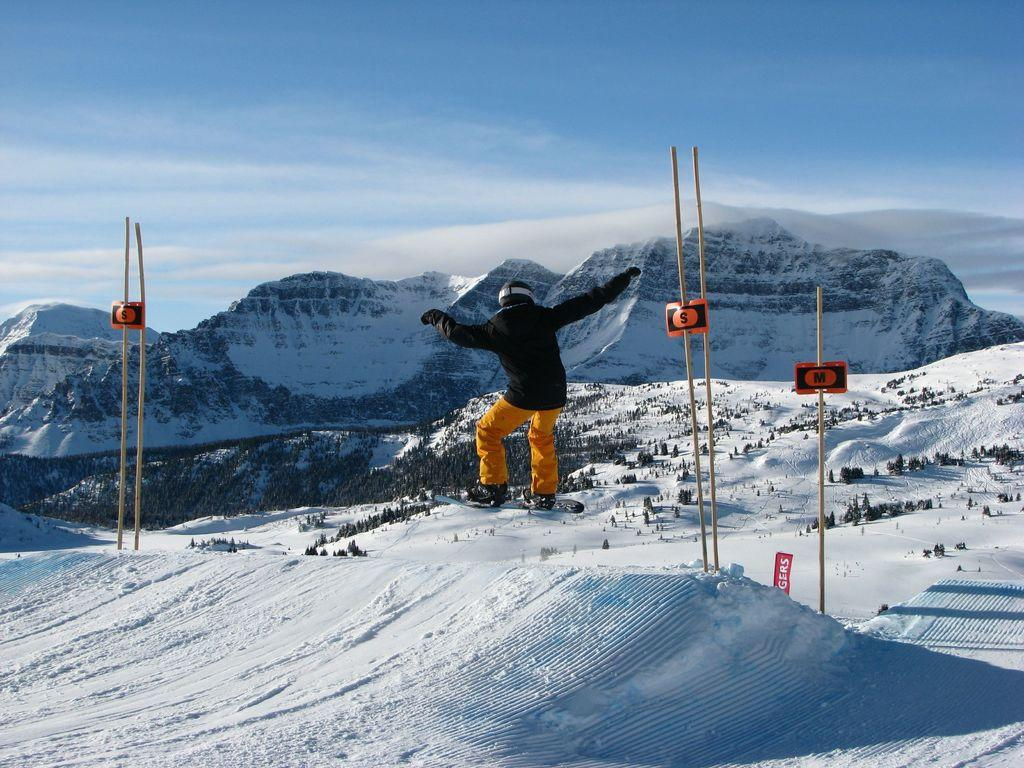What is the person in the image doing? There is a person skating in the image. What type of weather is depicted in the image? There is snow in the image. What objects can be seen in the image? There are sticks and hills visible in the image. What is visible in the background of the image? The sky is visible in the image, and clouds are present in the sky. How much debt does the person skating have in the image? There is no information about the person's debt in the image. 